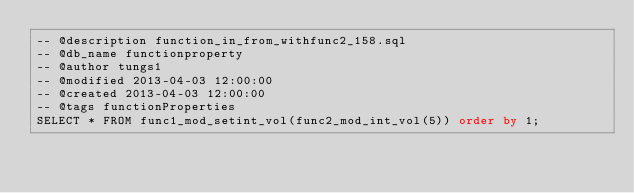<code> <loc_0><loc_0><loc_500><loc_500><_SQL_>-- @description function_in_from_withfunc2_158.sql
-- @db_name functionproperty
-- @author tungs1
-- @modified 2013-04-03 12:00:00
-- @created 2013-04-03 12:00:00
-- @tags functionProperties 
SELECT * FROM func1_mod_setint_vol(func2_mod_int_vol(5)) order by 1; 
</code> 